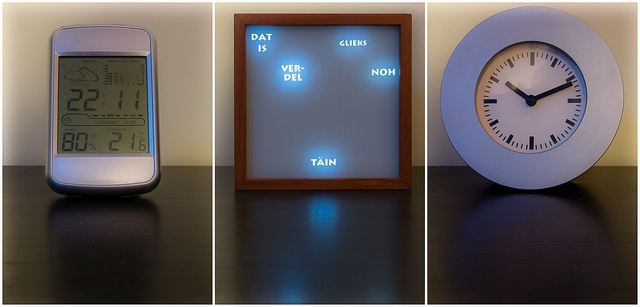Describe the objects in this image and their specific colors. I can see clock in white and gray tones and clock in white, darkgreen, darkgray, black, and gray tones in this image. 